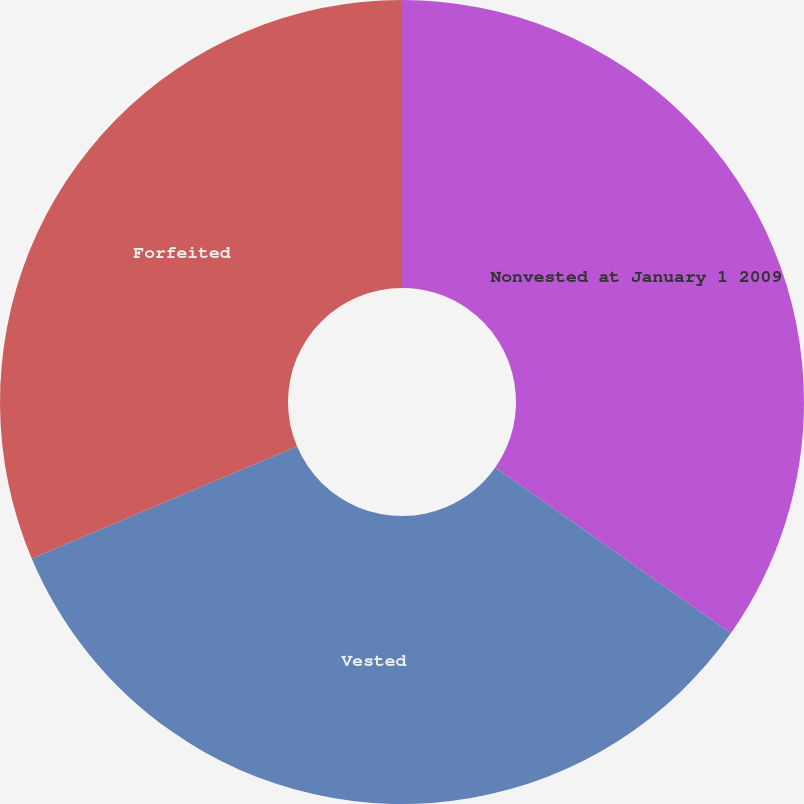Convert chart. <chart><loc_0><loc_0><loc_500><loc_500><pie_chart><fcel>Nonvested at January 1 2009<fcel>Vested<fcel>Forfeited<nl><fcel>34.75%<fcel>33.88%<fcel>31.36%<nl></chart> 